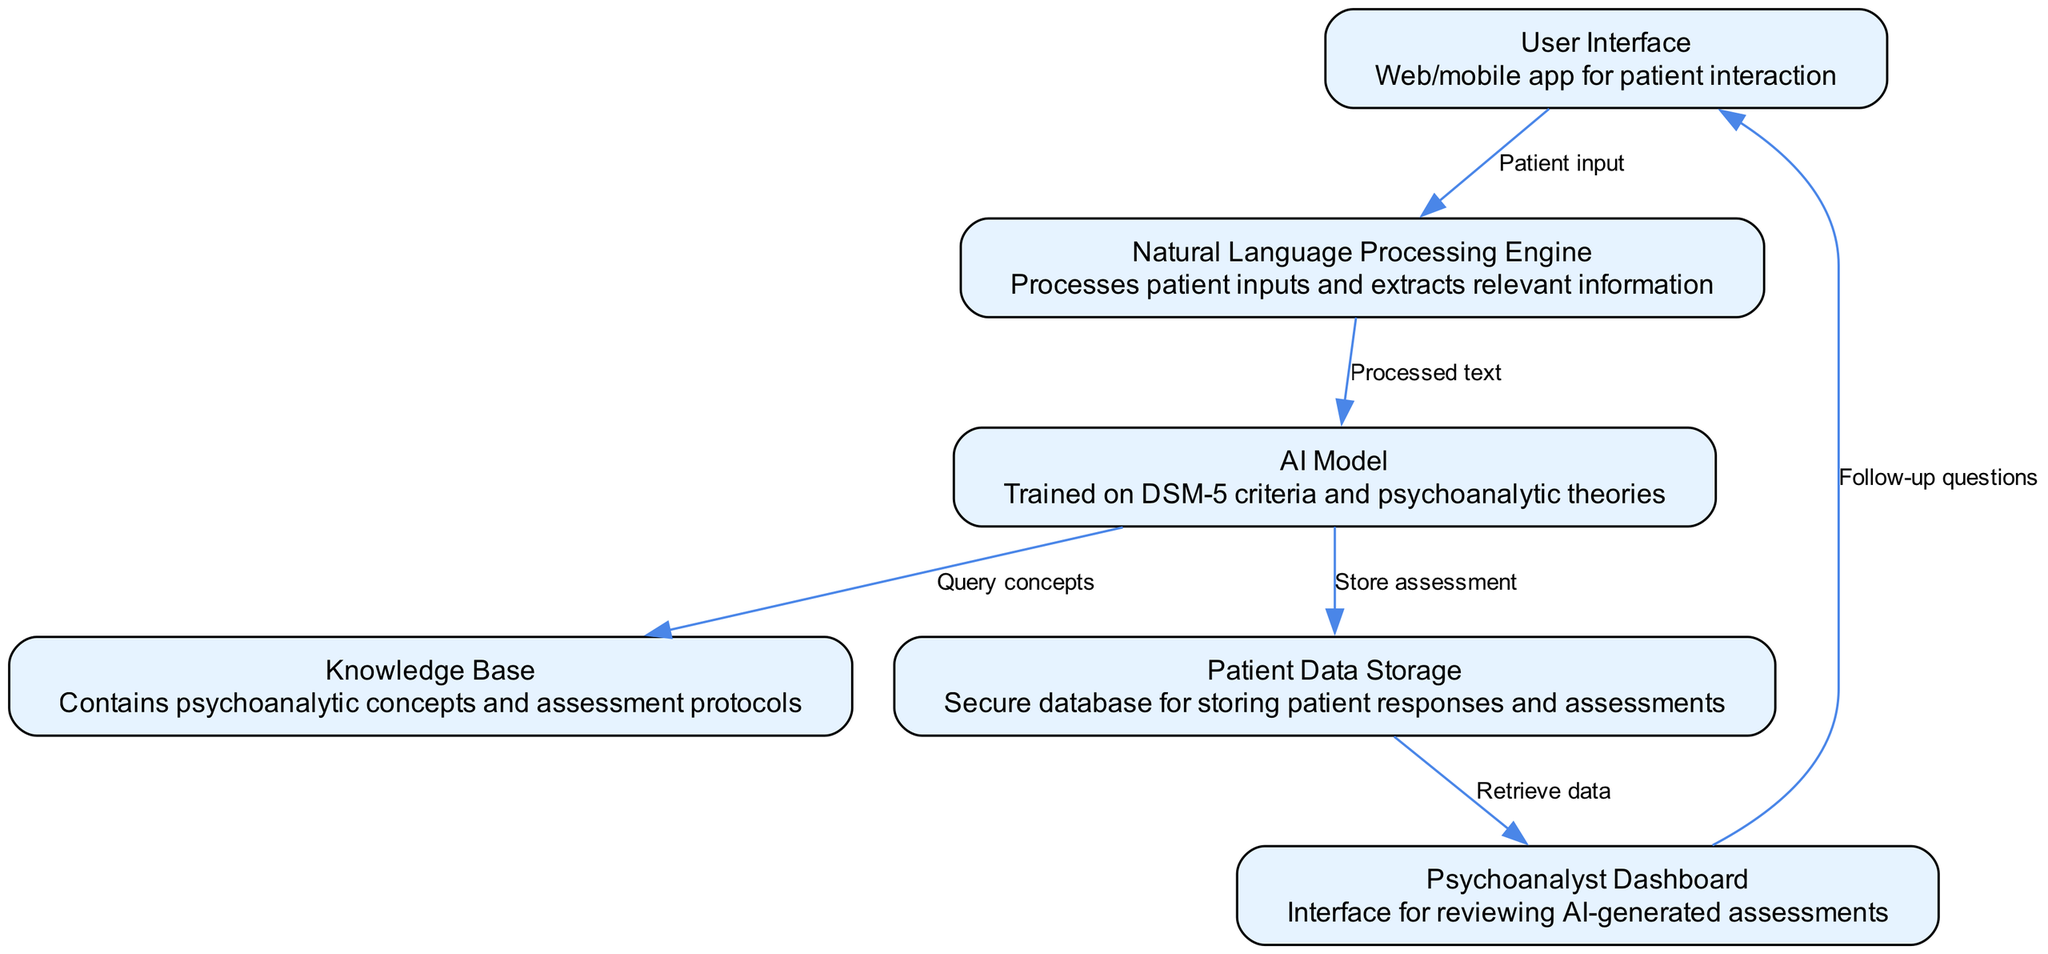What is the total number of nodes in the diagram? The diagram includes six distinct nodes: User Interface, Natural Language Processing Engine, AI Model, Knowledge Base, Patient Data Storage, and Psychoanalyst Dashboard. Therefore, the total count is determined by simply counting each separate entity shown.
Answer: 6 What is the function of the AI Model? The AI Model's purpose in the diagram is to be trained on DSM-5 criteria and psychoanalytic theories, serving as a critical component for understanding and processing patient information. This is deduced from the description provided in the node labeled "AI Model."
Answer: Trained on DSM-5 criteria and psychoanalytic theories Which node follows the Patient Data Storage in the flow? The flow of the diagram reveals that after Patient Data Storage, the next node is Psychoanalyst Dashboard. This is found by examining the connection or edge pointing from node 5 (Patient Data Storage) to node 6 (Psychoanalyst Dashboard).
Answer: Psychoanalyst Dashboard What type of data does the User Interface process? The User Interface processes patient input, as indicated by the edge labeled "Patient input" leading from node 1 (User Interface) to node 2 (Natural Language Processing Engine). It establishes how patients engage and input their data.
Answer: Patient input How many edges are there in the diagram? After assessing the components in the diagram, there are five edges linking the nodes, which move the assessment flow from one node to another. The edges highlight the relationships between the entities represented.
Answer: 5 What is the relationship between the AI Model and the Knowledge Base? The relationship is established through a directed edge indicating that the AI Model queries concepts from the Knowledge Base, which is vital for its function of extracting relevant information during assessments. This understanding comes from tracing the connection from node 3 (AI Model) to node 4 (Knowledge Base).
Answer: Query concepts 